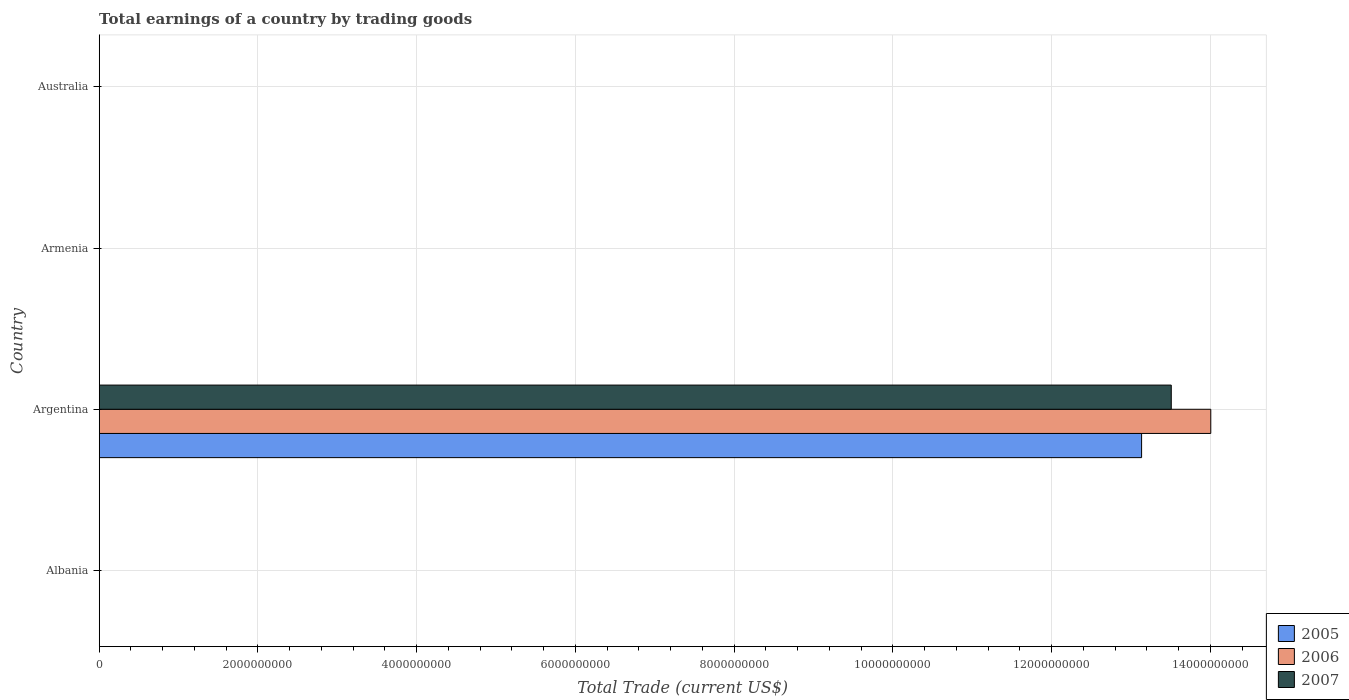How many bars are there on the 1st tick from the top?
Your answer should be compact. 0. How many bars are there on the 3rd tick from the bottom?
Your response must be concise. 0. What is the label of the 1st group of bars from the top?
Your answer should be very brief. Australia. What is the total earnings in 2005 in Argentina?
Ensure brevity in your answer.  1.31e+1. Across all countries, what is the maximum total earnings in 2007?
Make the answer very short. 1.35e+1. In which country was the total earnings in 2007 maximum?
Your response must be concise. Argentina. What is the total total earnings in 2006 in the graph?
Offer a very short reply. 1.40e+1. What is the difference between the total earnings in 2007 in Argentina and the total earnings in 2006 in Australia?
Offer a very short reply. 1.35e+1. What is the average total earnings in 2006 per country?
Offer a very short reply. 3.50e+09. What is the difference between the total earnings in 2006 and total earnings in 2005 in Argentina?
Provide a short and direct response. 8.72e+08. What is the difference between the highest and the lowest total earnings in 2006?
Offer a terse response. 1.40e+1. In how many countries, is the total earnings in 2006 greater than the average total earnings in 2006 taken over all countries?
Your response must be concise. 1. Is it the case that in every country, the sum of the total earnings in 2007 and total earnings in 2005 is greater than the total earnings in 2006?
Make the answer very short. No. Are all the bars in the graph horizontal?
Your answer should be compact. Yes. How many countries are there in the graph?
Your response must be concise. 4. What is the difference between two consecutive major ticks on the X-axis?
Make the answer very short. 2.00e+09. Are the values on the major ticks of X-axis written in scientific E-notation?
Your answer should be compact. No. Where does the legend appear in the graph?
Provide a short and direct response. Bottom right. How many legend labels are there?
Your answer should be very brief. 3. What is the title of the graph?
Ensure brevity in your answer.  Total earnings of a country by trading goods. Does "1969" appear as one of the legend labels in the graph?
Make the answer very short. No. What is the label or title of the X-axis?
Ensure brevity in your answer.  Total Trade (current US$). What is the label or title of the Y-axis?
Give a very brief answer. Country. What is the Total Trade (current US$) in 2006 in Albania?
Provide a short and direct response. 0. What is the Total Trade (current US$) of 2005 in Argentina?
Offer a very short reply. 1.31e+1. What is the Total Trade (current US$) of 2006 in Argentina?
Your answer should be compact. 1.40e+1. What is the Total Trade (current US$) in 2007 in Argentina?
Make the answer very short. 1.35e+1. What is the Total Trade (current US$) of 2006 in Armenia?
Make the answer very short. 0. What is the Total Trade (current US$) in 2006 in Australia?
Keep it short and to the point. 0. What is the Total Trade (current US$) of 2007 in Australia?
Your answer should be compact. 0. Across all countries, what is the maximum Total Trade (current US$) of 2005?
Give a very brief answer. 1.31e+1. Across all countries, what is the maximum Total Trade (current US$) in 2006?
Your response must be concise. 1.40e+1. Across all countries, what is the maximum Total Trade (current US$) in 2007?
Provide a short and direct response. 1.35e+1. What is the total Total Trade (current US$) of 2005 in the graph?
Ensure brevity in your answer.  1.31e+1. What is the total Total Trade (current US$) of 2006 in the graph?
Make the answer very short. 1.40e+1. What is the total Total Trade (current US$) in 2007 in the graph?
Your answer should be very brief. 1.35e+1. What is the average Total Trade (current US$) of 2005 per country?
Your answer should be very brief. 3.28e+09. What is the average Total Trade (current US$) of 2006 per country?
Offer a very short reply. 3.50e+09. What is the average Total Trade (current US$) of 2007 per country?
Your answer should be very brief. 3.38e+09. What is the difference between the Total Trade (current US$) of 2005 and Total Trade (current US$) of 2006 in Argentina?
Offer a terse response. -8.72e+08. What is the difference between the Total Trade (current US$) in 2005 and Total Trade (current US$) in 2007 in Argentina?
Your response must be concise. -3.74e+08. What is the difference between the Total Trade (current US$) of 2006 and Total Trade (current US$) of 2007 in Argentina?
Offer a terse response. 4.98e+08. What is the difference between the highest and the lowest Total Trade (current US$) in 2005?
Make the answer very short. 1.31e+1. What is the difference between the highest and the lowest Total Trade (current US$) in 2006?
Your response must be concise. 1.40e+1. What is the difference between the highest and the lowest Total Trade (current US$) in 2007?
Offer a very short reply. 1.35e+1. 